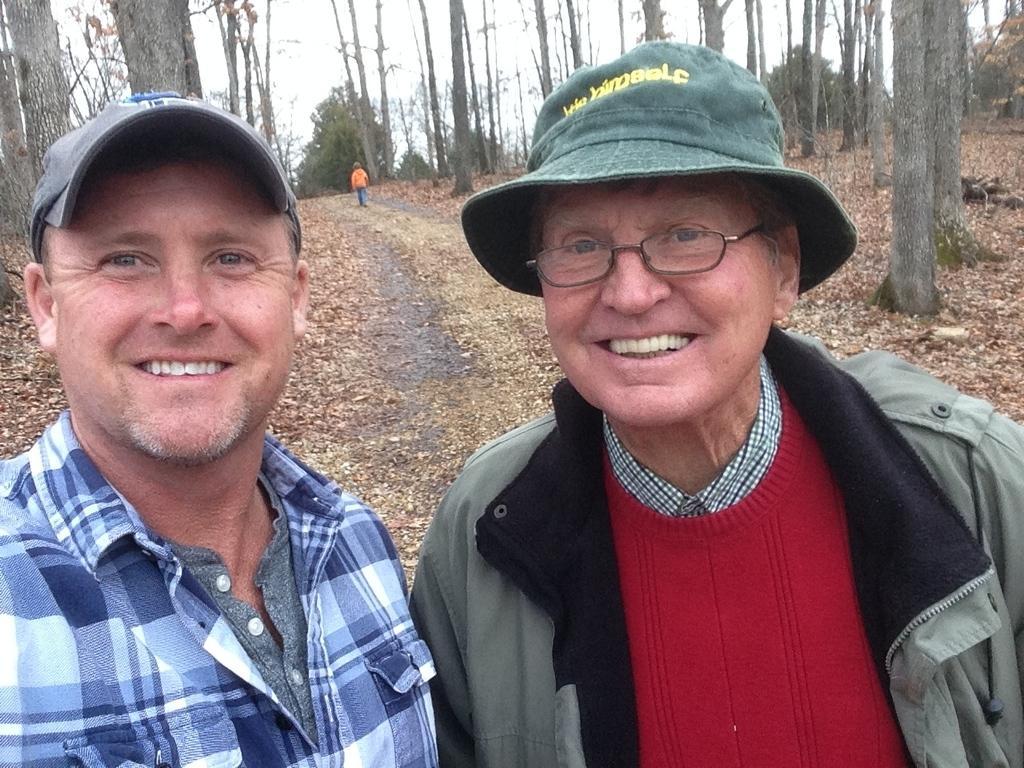Please provide a concise description of this image. In the foreground of this image, there are two men wearing hats and having smile on their faces. In the background, there are trees, sky and a boy walking on the path. 